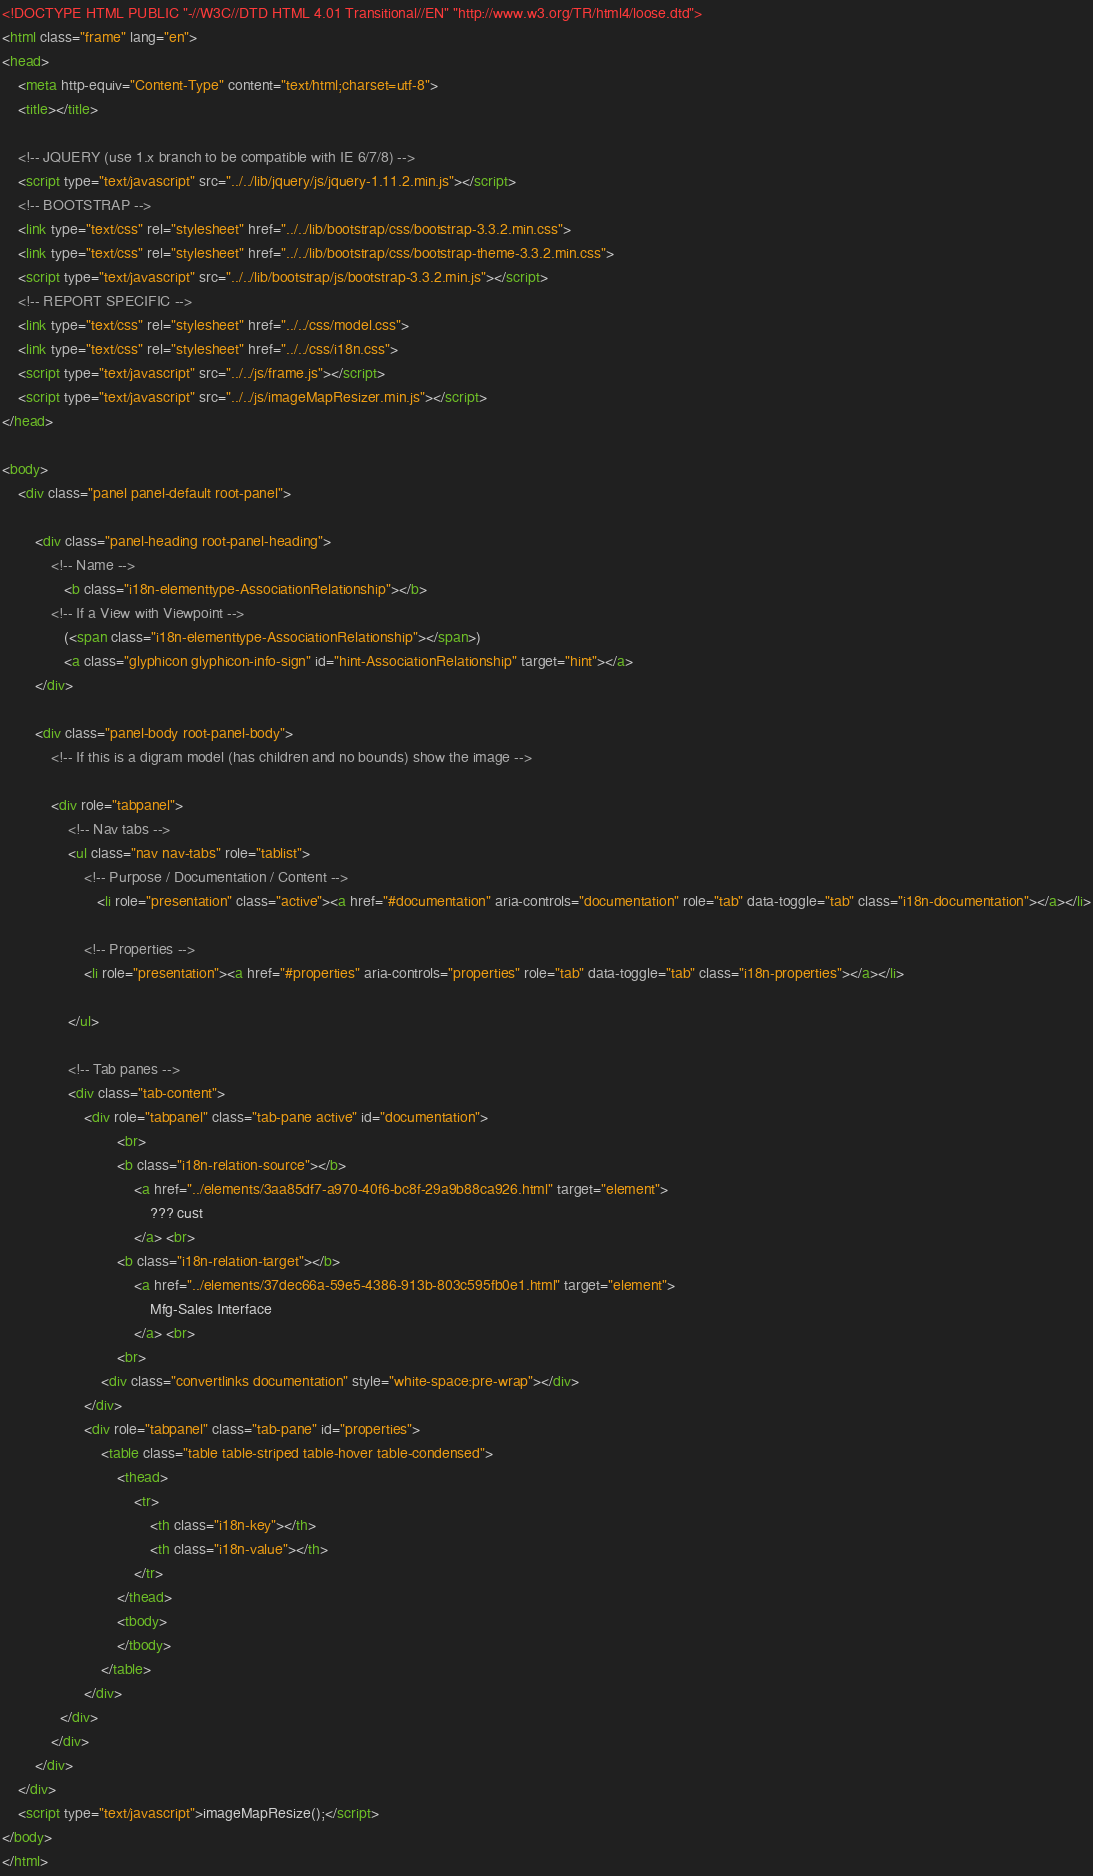<code> <loc_0><loc_0><loc_500><loc_500><_HTML_><!DOCTYPE HTML PUBLIC "-//W3C//DTD HTML 4.01 Transitional//EN" "http://www.w3.org/TR/html4/loose.dtd">
<html class="frame" lang="en">
<head>
	<meta http-equiv="Content-Type" content="text/html;charset=utf-8">
	<title></title>

	<!-- JQUERY (use 1.x branch to be compatible with IE 6/7/8) -->
	<script type="text/javascript" src="../../lib/jquery/js/jquery-1.11.2.min.js"></script>
	<!-- BOOTSTRAP -->
	<link type="text/css" rel="stylesheet" href="../../lib/bootstrap/css/bootstrap-3.3.2.min.css">
	<link type="text/css" rel="stylesheet" href="../../lib/bootstrap/css/bootstrap-theme-3.3.2.min.css">
	<script type="text/javascript" src="../../lib/bootstrap/js/bootstrap-3.3.2.min.js"></script>
	<!-- REPORT SPECIFIC -->
	<link type="text/css" rel="stylesheet" href="../../css/model.css">
	<link type="text/css" rel="stylesheet" href="../../css/i18n.css">
	<script type="text/javascript" src="../../js/frame.js"></script>
	<script type="text/javascript" src="../../js/imageMapResizer.min.js"></script>
</head>

<body>
	<div class="panel panel-default root-panel">

		<div class="panel-heading root-panel-heading">
            <!-- Name -->
               <b class="i18n-elementtype-AssociationRelationship"></b>
            <!-- If a View with Viewpoint -->
			   (<span class="i18n-elementtype-AssociationRelationship"></span>)
			   <a class="glyphicon glyphicon-info-sign" id="hint-AssociationRelationship" target="hint"></a>
		</div>

		<div class="panel-body root-panel-body">
		    <!-- If this is a digram model (has children and no bounds) show the image -->

			<div role="tabpanel">
				<!-- Nav tabs -->
				<ul class="nav nav-tabs" role="tablist">
                    <!-- Purpose / Documentation / Content -->
					   <li role="presentation" class="active"><a href="#documentation" aria-controls="documentation" role="tab" data-toggle="tab" class="i18n-documentation"></a></li>

                    <!-- Properties -->
                    <li role="presentation"><a href="#properties" aria-controls="properties" role="tab" data-toggle="tab" class="i18n-properties"></a></li>

				</ul>

				<!-- Tab panes -->
				<div class="tab-content">
					<div role="tabpanel" class="tab-pane active" id="documentation">
							<br>
							<b class="i18n-relation-source"></b>
								<a href="../elements/3aa85df7-a970-40f6-bc8f-29a9b88ca926.html" target="element">
									??? cust
								</a> <br>
							<b class="i18n-relation-target"></b>
								<a href="../elements/37dec66a-59e5-4386-913b-803c595fb0e1.html" target="element">
									Mfg-Sales Interface
								</a> <br>
							<br>
						<div class="convertlinks documentation" style="white-space:pre-wrap"></div>
					</div>
					<div role="tabpanel" class="tab-pane" id="properties">
						<table class="table table-striped table-hover table-condensed">
							<thead>
								<tr>
									<th class="i18n-key"></th>
									<th class="i18n-value"></th>
								</tr>
							</thead>
							<tbody>
							</tbody>
						</table>
					</div>
			  </div>
			</div>
		</div>
	</div>
	<script type="text/javascript">imageMapResize();</script>
</body>
</html></code> 